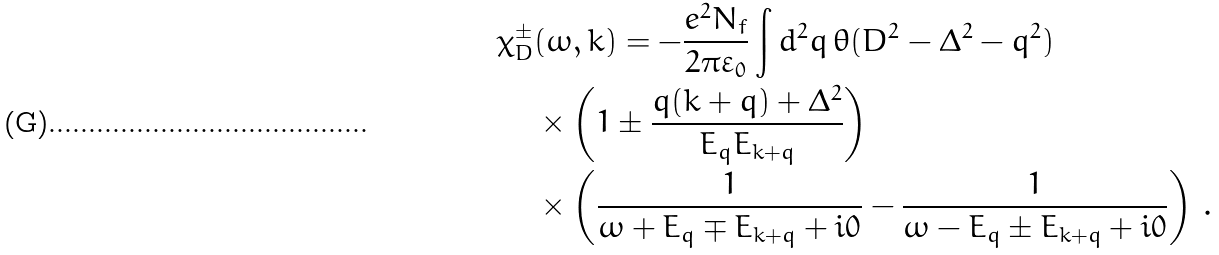Convert formula to latex. <formula><loc_0><loc_0><loc_500><loc_500>\chi _ { D } ^ { \pm } & ( \omega , k ) = - \frac { e ^ { 2 } N _ { f } } { 2 \pi \varepsilon _ { 0 } } \int d ^ { 2 } q \, \theta ( D ^ { 2 } - \Delta ^ { 2 } - q ^ { 2 } ) \\ & \times \left ( 1 \pm \frac { { q } ( { k } + { q } ) + \Delta ^ { 2 } } { E _ { q } E _ { { k } + { q } } } \right ) \\ & \times \left ( \frac { 1 } { \omega + E _ { q } \mp E _ { { k } + { q } } + i 0 } - \frac { 1 } { \omega - E _ { q } \pm E _ { { k } + { q } } + i 0 } \right ) \, .</formula> 